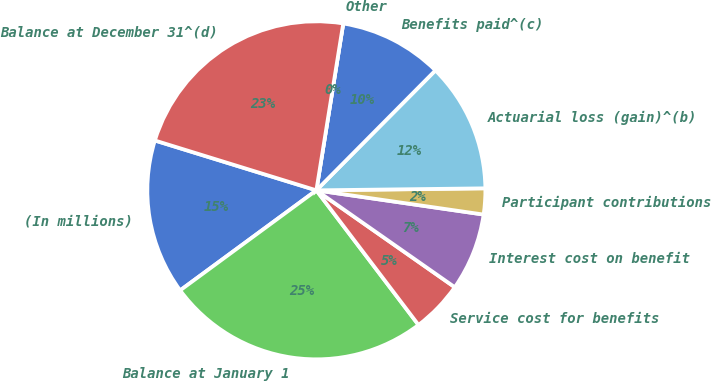<chart> <loc_0><loc_0><loc_500><loc_500><pie_chart><fcel>(In millions)<fcel>Balance at January 1<fcel>Service cost for benefits<fcel>Interest cost on benefit<fcel>Participant contributions<fcel>Actuarial loss (gain)^(b)<fcel>Benefits paid^(c)<fcel>Other<fcel>Balance at December 31^(d)<nl><fcel>14.85%<fcel>25.25%<fcel>4.95%<fcel>7.43%<fcel>2.48%<fcel>12.37%<fcel>9.9%<fcel>0.0%<fcel>22.78%<nl></chart> 